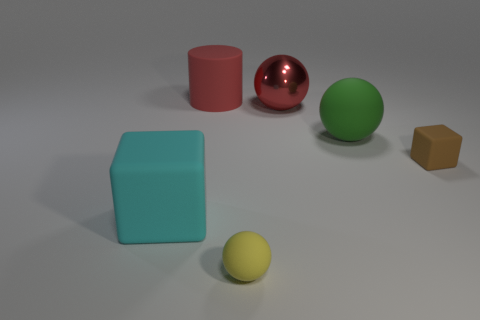What material is the ball that is on the left side of the large green rubber object and behind the brown rubber object?
Make the answer very short. Metal. Is there anything else that is the same color as the big rubber ball?
Keep it short and to the point. No. Are there fewer tiny objects that are behind the large matte cylinder than red matte cylinders?
Your answer should be very brief. Yes. Are there more green matte objects than big blue objects?
Your answer should be compact. Yes. Is there a small brown matte block that is on the left side of the tiny rubber thing right of the big green object that is on the right side of the large block?
Your answer should be compact. No. How many other objects are there of the same size as the green matte thing?
Your answer should be very brief. 3. There is a cyan matte block; are there any green rubber balls on the left side of it?
Keep it short and to the point. No. Is the color of the large matte cube the same as the small rubber thing that is to the right of the metal object?
Provide a short and direct response. No. What color is the tiny rubber thing behind the rubber object on the left side of the large red object that is to the left of the tiny rubber ball?
Make the answer very short. Brown. Are there any other metallic things of the same shape as the large red metallic object?
Offer a terse response. No. 